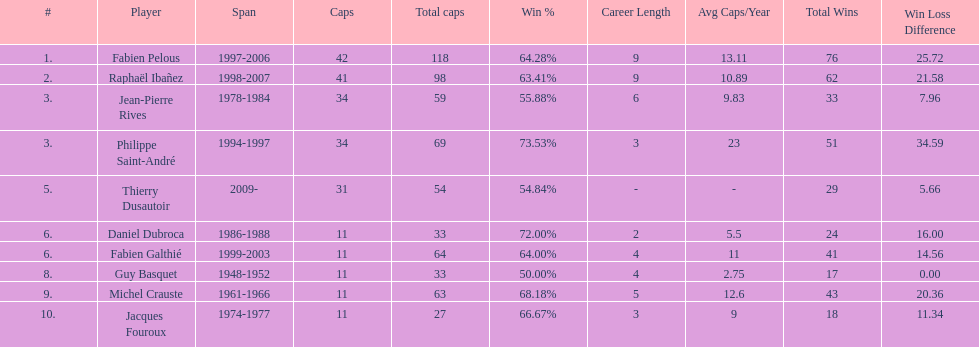What was the length of michel crauste's captaincy? 1961-1966. 